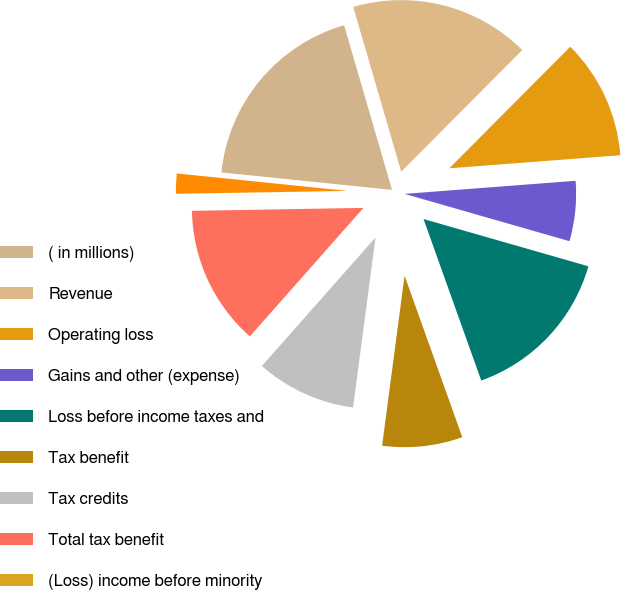<chart> <loc_0><loc_0><loc_500><loc_500><pie_chart><fcel>( in millions)<fcel>Revenue<fcel>Operating loss<fcel>Gains and other (expense)<fcel>Loss before income taxes and<fcel>Tax benefit<fcel>Tax credits<fcel>Total tax benefit<fcel>(Loss) income before minority<fcel>(Loss) income on discontinued<nl><fcel>18.86%<fcel>16.97%<fcel>11.32%<fcel>5.66%<fcel>15.09%<fcel>7.55%<fcel>9.43%<fcel>13.2%<fcel>0.01%<fcel>1.89%<nl></chart> 